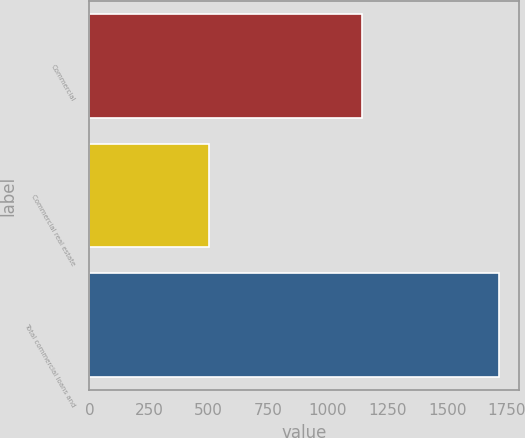Convert chart. <chart><loc_0><loc_0><loc_500><loc_500><bar_chart><fcel>Commercial<fcel>Commercial real estate<fcel>Total commercial loans and<nl><fcel>1143<fcel>500<fcel>1716<nl></chart> 